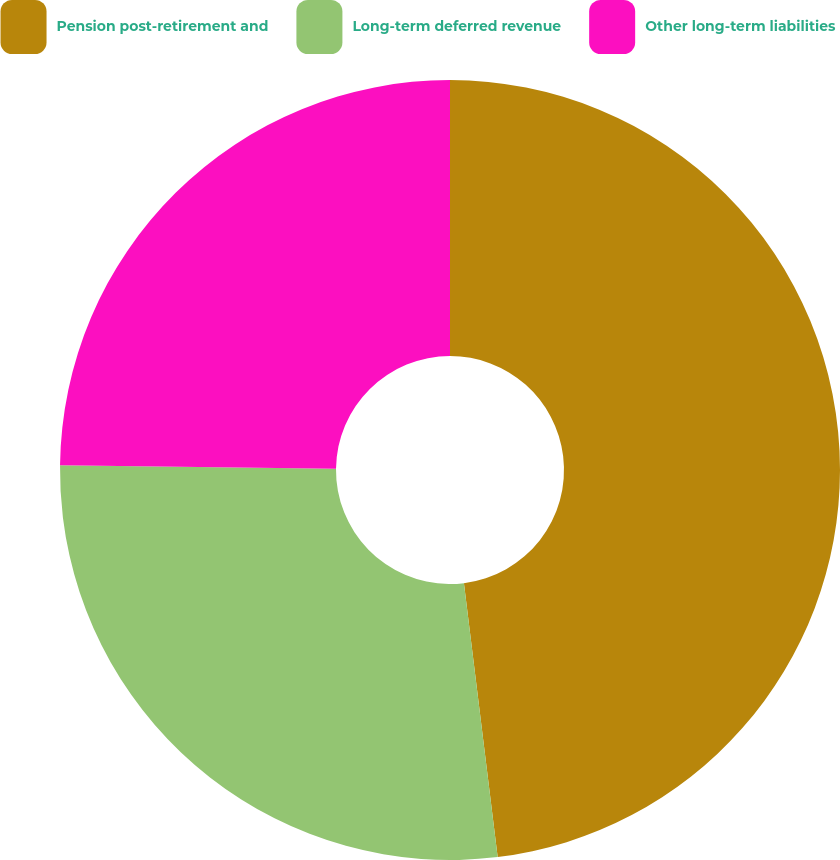<chart> <loc_0><loc_0><loc_500><loc_500><pie_chart><fcel>Pension post-retirement and<fcel>Long-term deferred revenue<fcel>Other long-term liabilities<nl><fcel>48.05%<fcel>27.14%<fcel>24.81%<nl></chart> 